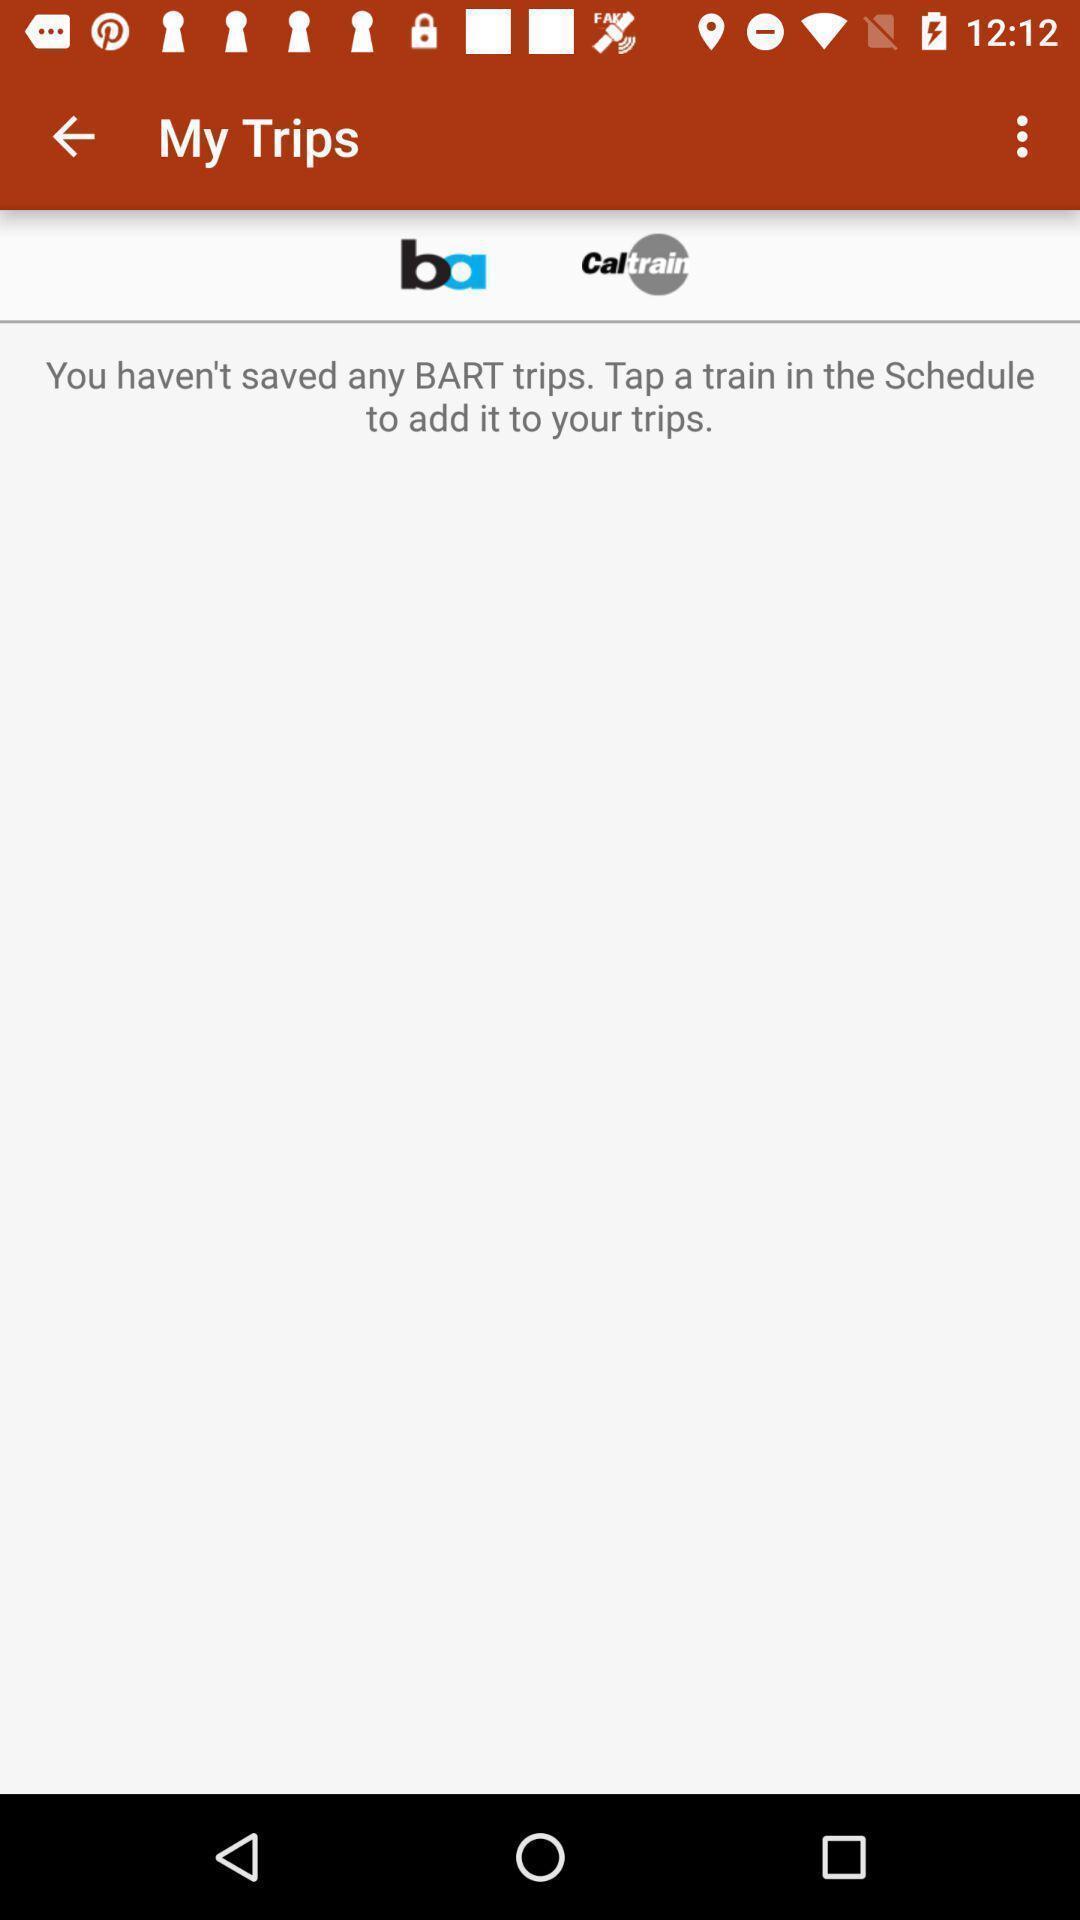Tell me about the visual elements in this screen capture. Page displaying search results for my trips. 